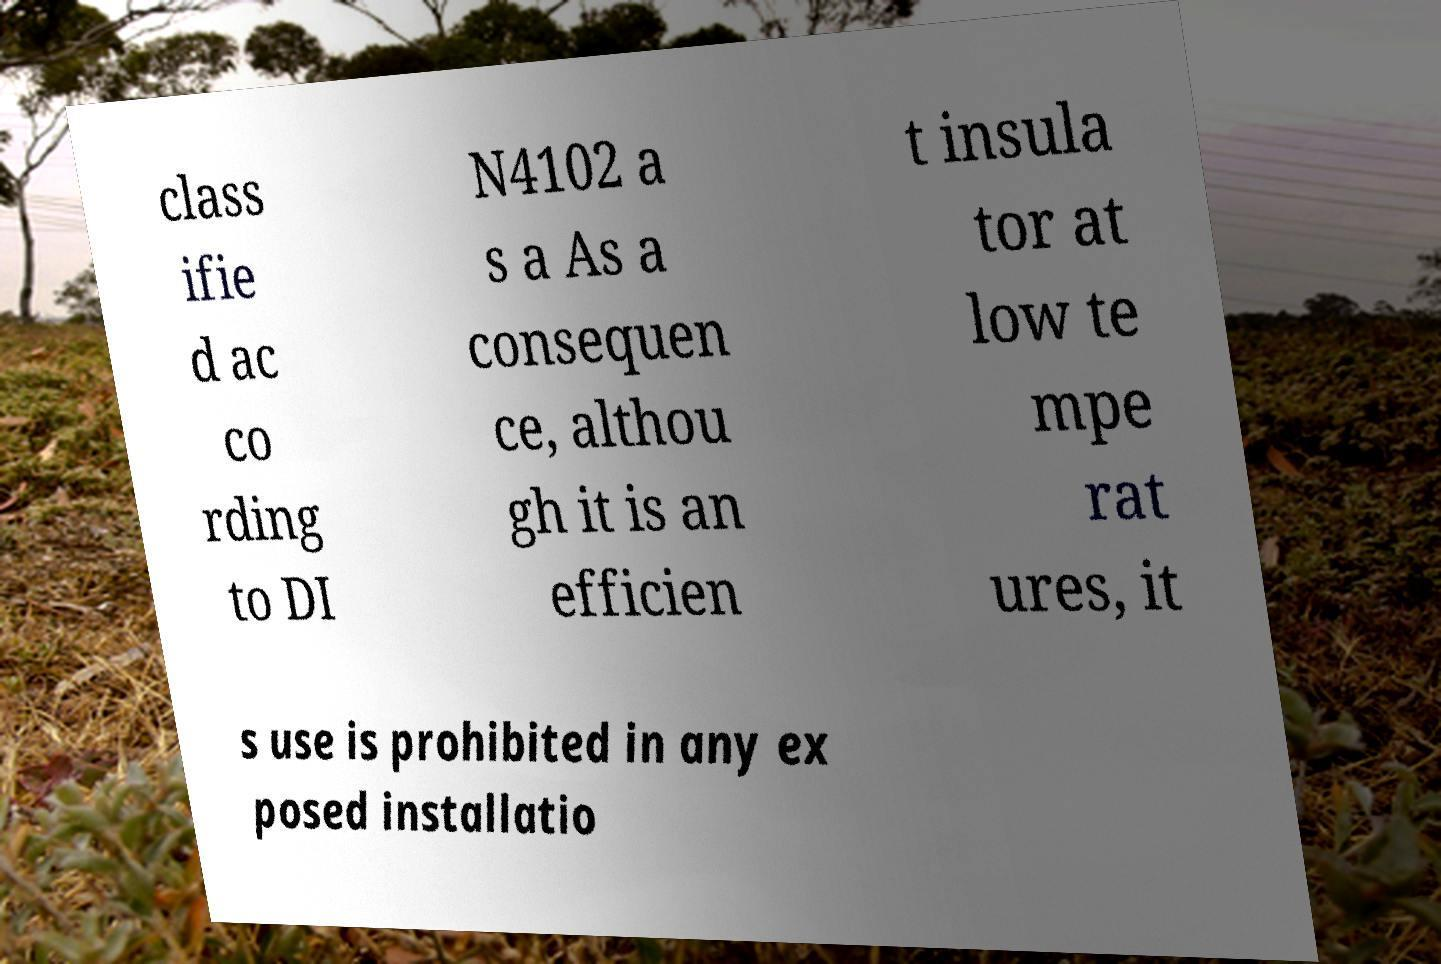What messages or text are displayed in this image? I need them in a readable, typed format. class ifie d ac co rding to DI N4102 a s a As a consequen ce, althou gh it is an efficien t insula tor at low te mpe rat ures, it s use is prohibited in any ex posed installatio 